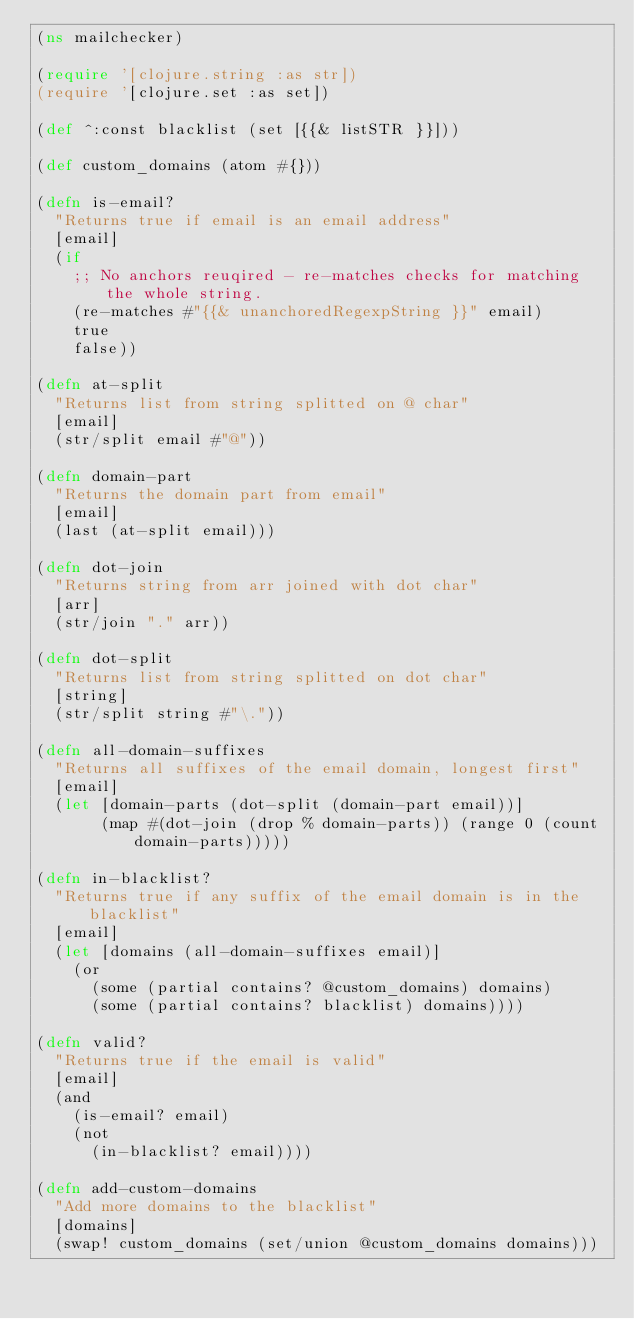Convert code to text. <code><loc_0><loc_0><loc_500><loc_500><_Clojure_>(ns mailchecker)

(require '[clojure.string :as str])
(require '[clojure.set :as set])

(def ^:const blacklist (set [{{& listSTR }}]))

(def custom_domains (atom #{}))

(defn is-email?
  "Returns true if email is an email address"
  [email]
  (if
    ;; No anchors reuqired - re-matches checks for matching the whole string.
    (re-matches #"{{& unanchoredRegexpString }}" email)
    true
    false))

(defn at-split
  "Returns list from string splitted on @ char"
  [email]
  (str/split email #"@"))

(defn domain-part
  "Returns the domain part from email"
  [email]
  (last (at-split email)))

(defn dot-join
  "Returns string from arr joined with dot char"
  [arr]
  (str/join "." arr))

(defn dot-split
  "Returns list from string splitted on dot char"
  [string]
  (str/split string #"\."))

(defn all-domain-suffixes
  "Returns all suffixes of the email domain, longest first"
  [email]
  (let [domain-parts (dot-split (domain-part email))]
       (map #(dot-join (drop % domain-parts)) (range 0 (count domain-parts)))))

(defn in-blacklist?
  "Returns true if any suffix of the email domain is in the blacklist"
  [email]
  (let [domains (all-domain-suffixes email)]
    (or
      (some (partial contains? @custom_domains) domains)
      (some (partial contains? blacklist) domains))))

(defn valid?
  "Returns true if the email is valid"
  [email]
  (and
    (is-email? email)
    (not
      (in-blacklist? email))))

(defn add-custom-domains
  "Add more domains to the blacklist"
  [domains]
  (swap! custom_domains (set/union @custom_domains domains)))
</code> 